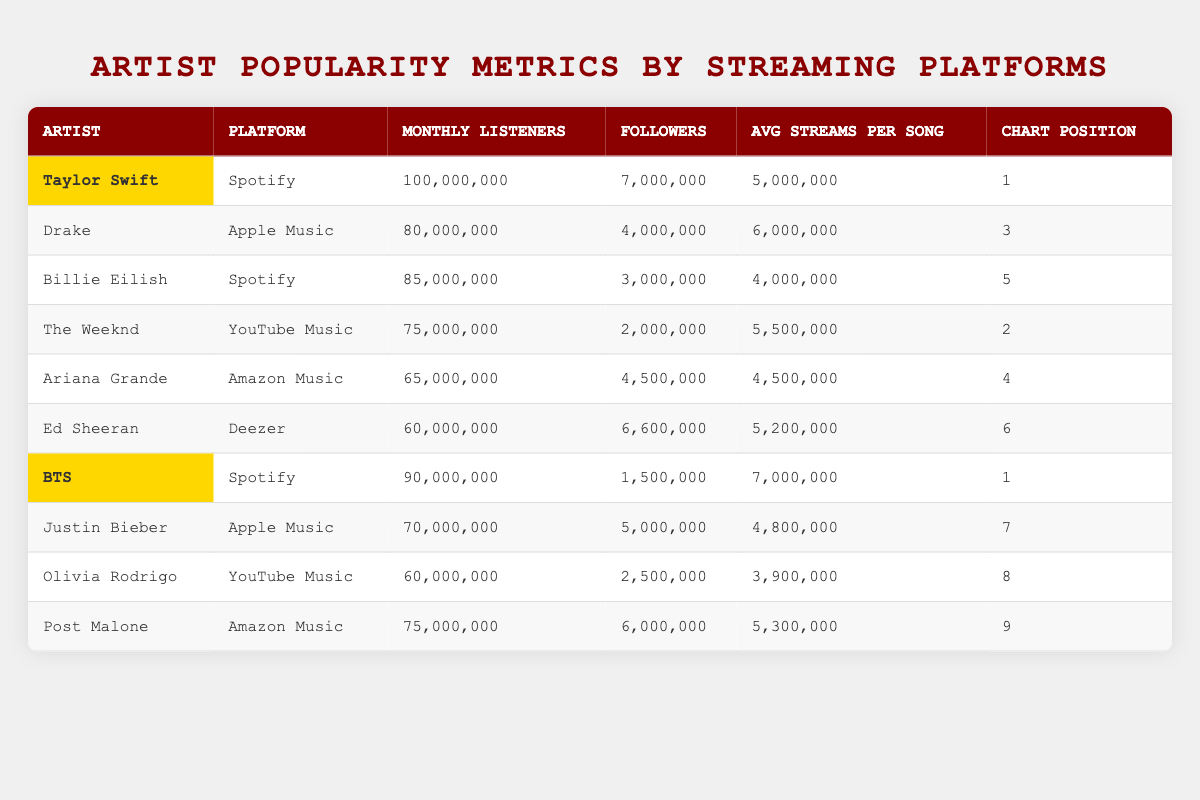What is the monthly listener count for Taylor Swift on Spotify? The table lists Taylor Swift's monthly listeners under the Spotify row as 100,000,000.
Answer: 100,000,000 Which artist has the highest average streams per song? By comparing the "Avg Streams Per Song" column, BTS has the highest at 7,000,000.
Answer: BTS Is Billie Eilish more popular than Justin Bieber based on monthly listeners? Billie Eilish has 85,000,000 monthly listeners while Justin Bieber has 70,000,000. Since 85,000,000 is greater than 70,000,000, Billie Eilish is more popular in this regard.
Answer: Yes What is the total number of monthly listeners for artists on YouTube Music? The monthly listeners for YouTube Music are 75,000,000 (The Weeknd) + 60,000,000 (Olivia Rodrigo) = 135,000,000.
Answer: 135,000,000 Which artist has the highest number of followers on their respective platform? Taylor Swift has the highest number of followers on Spotify with 7,000,000.
Answer: Taylor Swift Are there any artists with the same chart position? BTS and Taylor Swift both hold the chart position of 1. This indicates that they share the top spot.
Answer: Yes What is the difference in monthly listeners between BTS and Ariana Grande? BTS has 90,000,000 monthly listeners, and Ariana Grande has 65,000,000. The difference is 90,000,000 - 65,000,000 = 25,000,000.
Answer: 25,000,000 Which platform has the lowest average streams per song among the artists listed? From the "Avg Streams Per Song" column, Olivia Rodrigo on YouTube Music has the lowest with 3,900,000.
Answer: Olivia Rodrigo on YouTube Music How do Taylor Swift's and Billie Eilish's chart positions compare? Taylor Swift has a chart position of 1, and Billie Eilish has a chart position of 5. Since 1 is better than 5, Taylor Swift ranks higher.
Answer: Taylor Swift ranks higher Which artist on Amazon Music has the most monthly listeners? Post Malone has 75,000,000 monthly listeners on Amazon Music, which is higher than Ariana Grande's 65,000,000.
Answer: Post Malone 